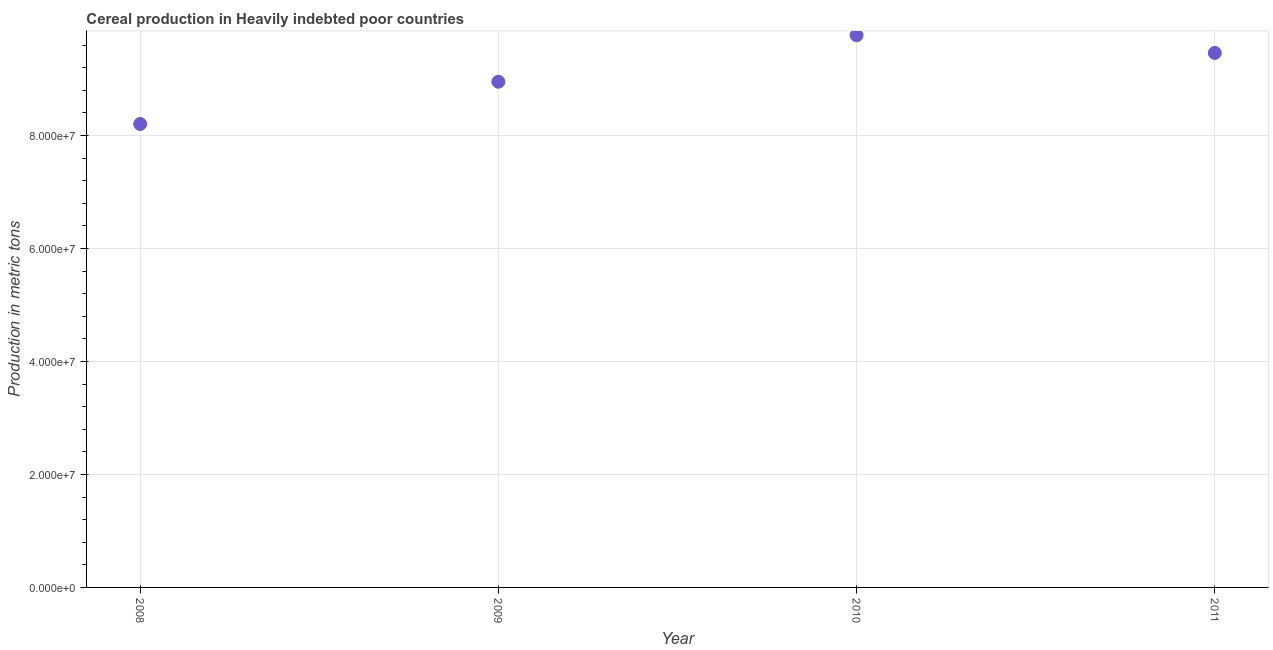What is the cereal production in 2011?
Your answer should be very brief. 9.46e+07. Across all years, what is the maximum cereal production?
Your answer should be very brief. 9.77e+07. Across all years, what is the minimum cereal production?
Offer a terse response. 8.20e+07. In which year was the cereal production maximum?
Your response must be concise. 2010. What is the sum of the cereal production?
Your answer should be very brief. 3.64e+08. What is the difference between the cereal production in 2009 and 2010?
Keep it short and to the point. -8.23e+06. What is the average cereal production per year?
Give a very brief answer. 9.10e+07. What is the median cereal production?
Keep it short and to the point. 9.21e+07. In how many years, is the cereal production greater than 48000000 metric tons?
Give a very brief answer. 4. Do a majority of the years between 2009 and 2011 (inclusive) have cereal production greater than 40000000 metric tons?
Make the answer very short. Yes. What is the ratio of the cereal production in 2008 to that in 2011?
Make the answer very short. 0.87. Is the difference between the cereal production in 2009 and 2011 greater than the difference between any two years?
Your answer should be compact. No. What is the difference between the highest and the second highest cereal production?
Provide a succinct answer. 3.13e+06. What is the difference between the highest and the lowest cereal production?
Give a very brief answer. 1.57e+07. In how many years, is the cereal production greater than the average cereal production taken over all years?
Keep it short and to the point. 2. Does the cereal production monotonically increase over the years?
Your answer should be compact. No. How many years are there in the graph?
Make the answer very short. 4. What is the difference between two consecutive major ticks on the Y-axis?
Offer a very short reply. 2.00e+07. Are the values on the major ticks of Y-axis written in scientific E-notation?
Give a very brief answer. Yes. What is the title of the graph?
Give a very brief answer. Cereal production in Heavily indebted poor countries. What is the label or title of the X-axis?
Give a very brief answer. Year. What is the label or title of the Y-axis?
Give a very brief answer. Production in metric tons. What is the Production in metric tons in 2008?
Offer a terse response. 8.20e+07. What is the Production in metric tons in 2009?
Ensure brevity in your answer.  8.95e+07. What is the Production in metric tons in 2010?
Provide a short and direct response. 9.77e+07. What is the Production in metric tons in 2011?
Keep it short and to the point. 9.46e+07. What is the difference between the Production in metric tons in 2008 and 2009?
Your response must be concise. -7.47e+06. What is the difference between the Production in metric tons in 2008 and 2010?
Provide a succinct answer. -1.57e+07. What is the difference between the Production in metric tons in 2008 and 2011?
Give a very brief answer. -1.26e+07. What is the difference between the Production in metric tons in 2009 and 2010?
Your answer should be compact. -8.23e+06. What is the difference between the Production in metric tons in 2009 and 2011?
Offer a very short reply. -5.10e+06. What is the difference between the Production in metric tons in 2010 and 2011?
Your answer should be compact. 3.13e+06. What is the ratio of the Production in metric tons in 2008 to that in 2009?
Provide a short and direct response. 0.92. What is the ratio of the Production in metric tons in 2008 to that in 2010?
Your answer should be compact. 0.84. What is the ratio of the Production in metric tons in 2008 to that in 2011?
Provide a short and direct response. 0.87. What is the ratio of the Production in metric tons in 2009 to that in 2010?
Provide a short and direct response. 0.92. What is the ratio of the Production in metric tons in 2009 to that in 2011?
Keep it short and to the point. 0.95. What is the ratio of the Production in metric tons in 2010 to that in 2011?
Ensure brevity in your answer.  1.03. 